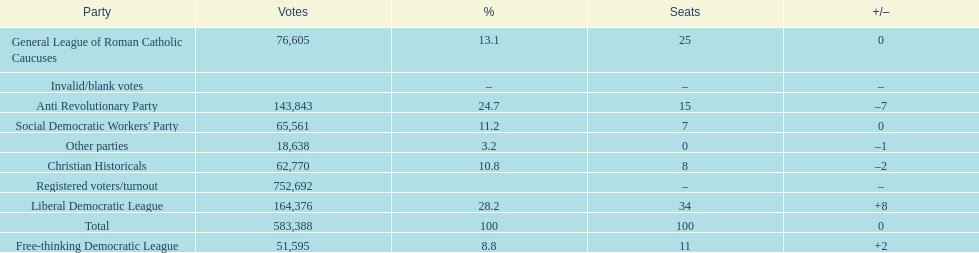How many more votes did the liberal democratic league win over the free-thinking democratic league? 112,781. 